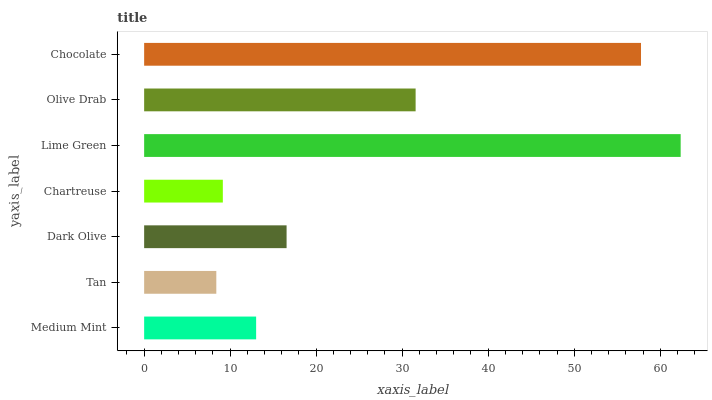Is Tan the minimum?
Answer yes or no. Yes. Is Lime Green the maximum?
Answer yes or no. Yes. Is Dark Olive the minimum?
Answer yes or no. No. Is Dark Olive the maximum?
Answer yes or no. No. Is Dark Olive greater than Tan?
Answer yes or no. Yes. Is Tan less than Dark Olive?
Answer yes or no. Yes. Is Tan greater than Dark Olive?
Answer yes or no. No. Is Dark Olive less than Tan?
Answer yes or no. No. Is Dark Olive the high median?
Answer yes or no. Yes. Is Dark Olive the low median?
Answer yes or no. Yes. Is Lime Green the high median?
Answer yes or no. No. Is Lime Green the low median?
Answer yes or no. No. 